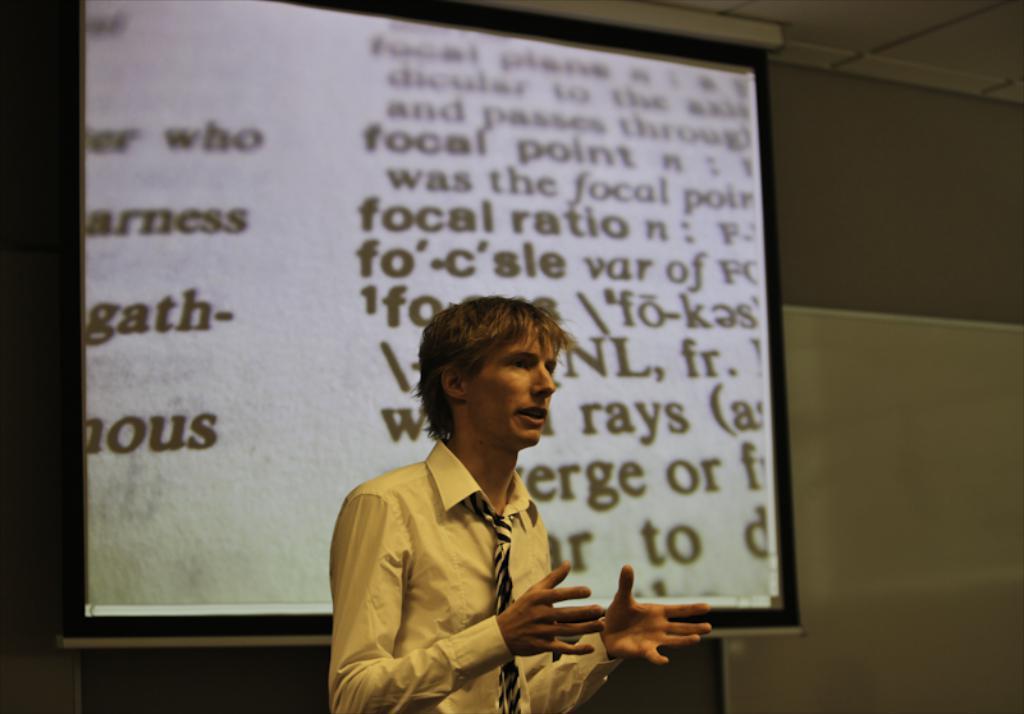Please provide a concise description of this image. There is a man standing and talking. In the background we can see screen and wall. 